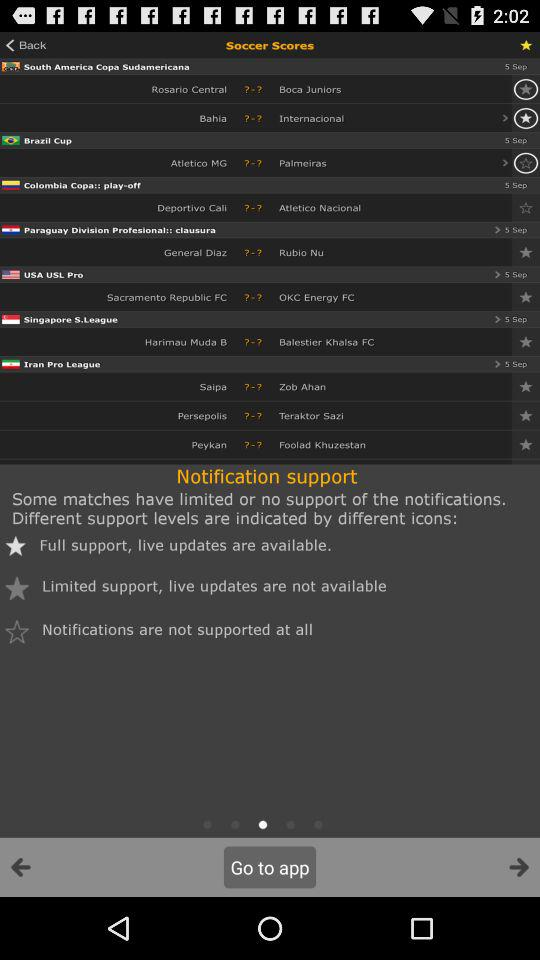What is the date for the "Brazil Cup"? The date for the "Brazil Cup" is September 5. 